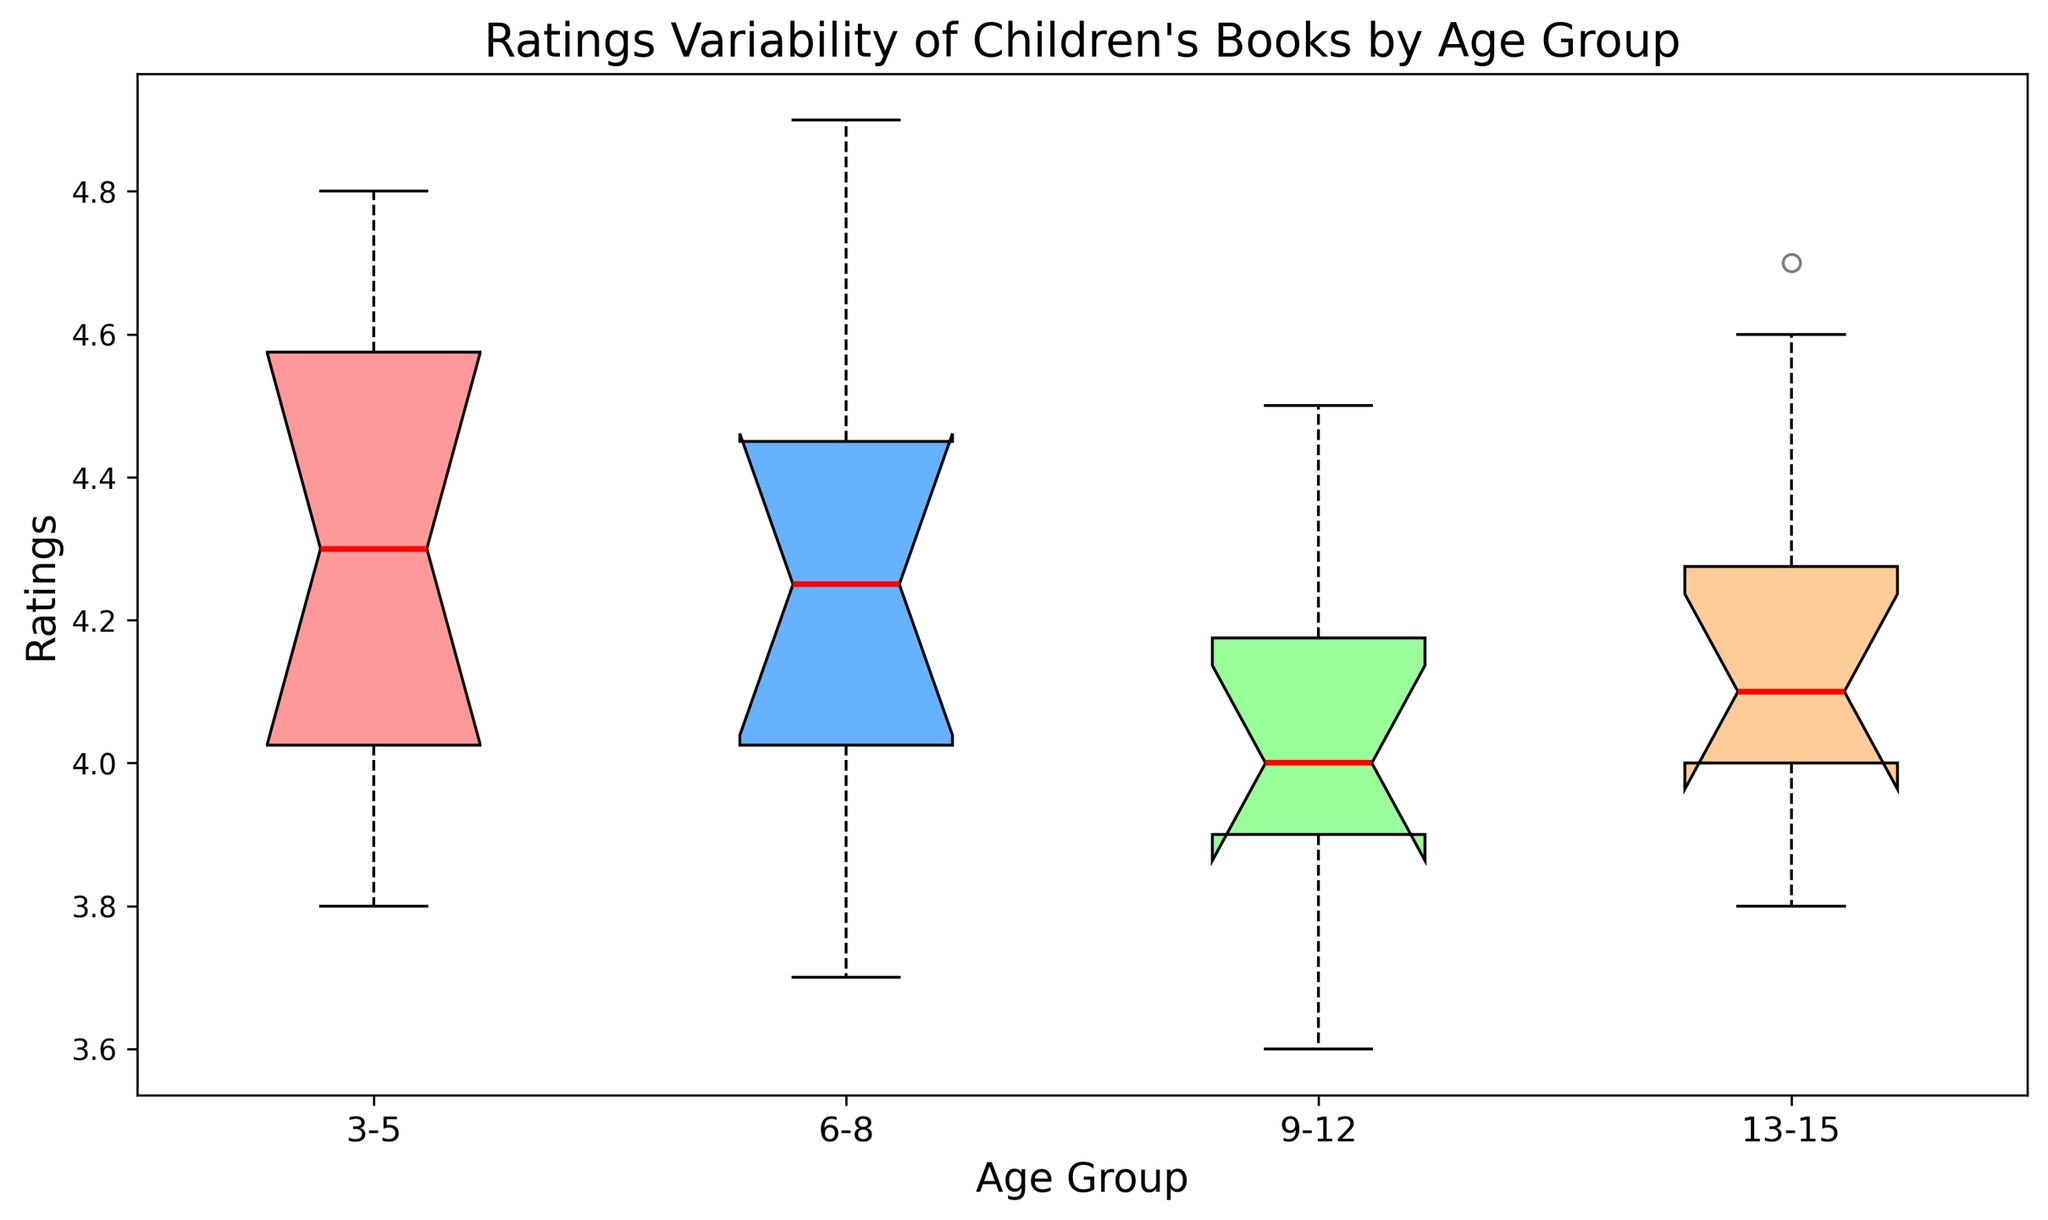Which age group has the highest median rating? The box plot shows the median ratings as red lines inside the boxes. To find the highest median, look for the longest red line.
Answer: 13-15 Which age group has the widest range of ratings? The range of ratings is represented by the spread between the top and bottom whiskers of the box plot. The widest range can be identified by the longest distance between these whiskers.
Answer: 6-8 What is the median rating for the 3-5 age group? The median rating is indicated by the red line inside the box for the 3-5 age group.
Answer: 4.4 Which age group has the most compact rating distribution? To assess compactness, we look for the box with the smallest height, representing a narrow interquartile range.
Answer: 13-15 Do any of the age groups have outliers, and if so, which ones? Outliers are indicated by points outside the whiskers of the box plot. Look for small circles which represent outliers.
Answer: 3-5 and 6-8 How does the third quartile of the 9-12 age group compare to the median of the 6-8 age group? The third quartile is the top edge of the blue box and the median is the red line. Compare the height of these two features between the age groups.
Answer: The third quartile of 9-12 is lower than the median of 6-8 What is the interquartile range (IQR) for the 13-15 age group? The IQR is the distance between the first quartile (bottom of box) and the third quartile (top of box). Subtract the lower quartile value from the upper quartile value.
Answer: 4.6 - 4.0 = 0.6 Which age group has the lowest minimum rating? The minimum rating for each group is indicated by the bottom whisker. Find the lowest point among all whiskers.
Answer: 3-5 and 9-12 How does the interquartile range (IQR) for the 3-5 age group compare to that of the 6-8 age group? Calculate the IQR for both groups by subtracting the first quartile (bottom of box) from the third quartile (top of box), then compare the two values.
Answer: IQR of 3-5 is smaller than IQR of 6-8 